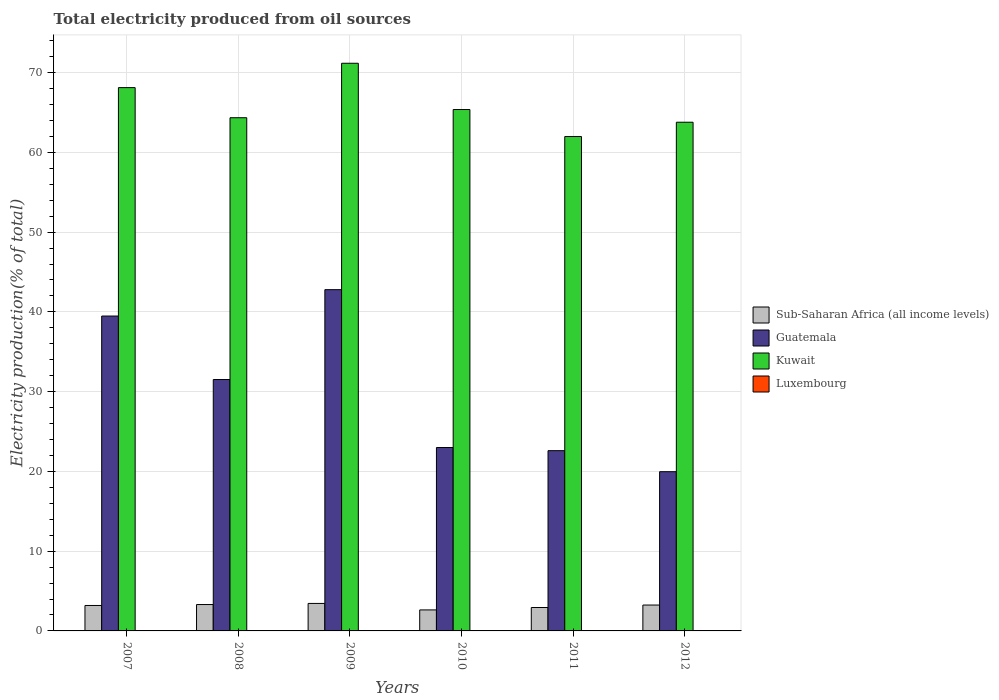How many bars are there on the 2nd tick from the left?
Make the answer very short. 4. How many bars are there on the 2nd tick from the right?
Ensure brevity in your answer.  4. What is the total electricity produced in Sub-Saharan Africa (all income levels) in 2011?
Your answer should be very brief. 2.94. Across all years, what is the maximum total electricity produced in Luxembourg?
Provide a short and direct response. 0.04. Across all years, what is the minimum total electricity produced in Luxembourg?
Keep it short and to the point. 0.03. In which year was the total electricity produced in Luxembourg minimum?
Your answer should be very brief. 2010. What is the total total electricity produced in Guatemala in the graph?
Your answer should be compact. 179.35. What is the difference between the total electricity produced in Sub-Saharan Africa (all income levels) in 2009 and that in 2011?
Offer a very short reply. 0.51. What is the difference between the total electricity produced in Kuwait in 2008 and the total electricity produced in Sub-Saharan Africa (all income levels) in 2007?
Your answer should be compact. 61.16. What is the average total electricity produced in Sub-Saharan Africa (all income levels) per year?
Offer a very short reply. 3.13. In the year 2010, what is the difference between the total electricity produced in Kuwait and total electricity produced in Sub-Saharan Africa (all income levels)?
Ensure brevity in your answer.  62.74. What is the ratio of the total electricity produced in Kuwait in 2008 to that in 2009?
Offer a terse response. 0.9. Is the total electricity produced in Luxembourg in 2009 less than that in 2012?
Your answer should be very brief. Yes. Is the difference between the total electricity produced in Kuwait in 2009 and 2011 greater than the difference between the total electricity produced in Sub-Saharan Africa (all income levels) in 2009 and 2011?
Keep it short and to the point. Yes. What is the difference between the highest and the second highest total electricity produced in Kuwait?
Offer a terse response. 3.06. What is the difference between the highest and the lowest total electricity produced in Kuwait?
Your answer should be very brief. 9.19. Is the sum of the total electricity produced in Kuwait in 2010 and 2011 greater than the maximum total electricity produced in Guatemala across all years?
Keep it short and to the point. Yes. Is it the case that in every year, the sum of the total electricity produced in Luxembourg and total electricity produced in Guatemala is greater than the sum of total electricity produced in Sub-Saharan Africa (all income levels) and total electricity produced in Kuwait?
Keep it short and to the point. Yes. What does the 1st bar from the left in 2009 represents?
Offer a terse response. Sub-Saharan Africa (all income levels). What does the 1st bar from the right in 2008 represents?
Offer a terse response. Luxembourg. How many bars are there?
Ensure brevity in your answer.  24. How many years are there in the graph?
Keep it short and to the point. 6. Are the values on the major ticks of Y-axis written in scientific E-notation?
Provide a succinct answer. No. Does the graph contain any zero values?
Your answer should be compact. No. How many legend labels are there?
Your answer should be compact. 4. How are the legend labels stacked?
Provide a succinct answer. Vertical. What is the title of the graph?
Offer a very short reply. Total electricity produced from oil sources. Does "Myanmar" appear as one of the legend labels in the graph?
Your answer should be compact. No. What is the label or title of the X-axis?
Your answer should be compact. Years. What is the Electricity production(% of total) in Sub-Saharan Africa (all income levels) in 2007?
Provide a succinct answer. 3.19. What is the Electricity production(% of total) in Guatemala in 2007?
Your response must be concise. 39.48. What is the Electricity production(% of total) of Kuwait in 2007?
Your answer should be very brief. 68.12. What is the Electricity production(% of total) in Luxembourg in 2007?
Provide a succinct answer. 0.03. What is the Electricity production(% of total) of Sub-Saharan Africa (all income levels) in 2008?
Keep it short and to the point. 3.31. What is the Electricity production(% of total) in Guatemala in 2008?
Your answer should be very brief. 31.52. What is the Electricity production(% of total) of Kuwait in 2008?
Ensure brevity in your answer.  64.35. What is the Electricity production(% of total) in Luxembourg in 2008?
Keep it short and to the point. 0.04. What is the Electricity production(% of total) of Sub-Saharan Africa (all income levels) in 2009?
Your answer should be very brief. 3.45. What is the Electricity production(% of total) of Guatemala in 2009?
Keep it short and to the point. 42.79. What is the Electricity production(% of total) in Kuwait in 2009?
Offer a very short reply. 71.18. What is the Electricity production(% of total) in Luxembourg in 2009?
Offer a very short reply. 0.03. What is the Electricity production(% of total) of Sub-Saharan Africa (all income levels) in 2010?
Give a very brief answer. 2.63. What is the Electricity production(% of total) of Guatemala in 2010?
Give a very brief answer. 23. What is the Electricity production(% of total) of Kuwait in 2010?
Offer a terse response. 65.38. What is the Electricity production(% of total) in Luxembourg in 2010?
Provide a succinct answer. 0.03. What is the Electricity production(% of total) of Sub-Saharan Africa (all income levels) in 2011?
Your response must be concise. 2.94. What is the Electricity production(% of total) of Guatemala in 2011?
Your answer should be very brief. 22.6. What is the Electricity production(% of total) of Kuwait in 2011?
Ensure brevity in your answer.  61.99. What is the Electricity production(% of total) of Luxembourg in 2011?
Ensure brevity in your answer.  0.04. What is the Electricity production(% of total) in Sub-Saharan Africa (all income levels) in 2012?
Keep it short and to the point. 3.24. What is the Electricity production(% of total) in Guatemala in 2012?
Provide a succinct answer. 19.96. What is the Electricity production(% of total) in Kuwait in 2012?
Your answer should be compact. 63.78. What is the Electricity production(% of total) in Luxembourg in 2012?
Provide a succinct answer. 0.04. Across all years, what is the maximum Electricity production(% of total) of Sub-Saharan Africa (all income levels)?
Keep it short and to the point. 3.45. Across all years, what is the maximum Electricity production(% of total) in Guatemala?
Make the answer very short. 42.79. Across all years, what is the maximum Electricity production(% of total) in Kuwait?
Offer a terse response. 71.18. Across all years, what is the maximum Electricity production(% of total) in Luxembourg?
Make the answer very short. 0.04. Across all years, what is the minimum Electricity production(% of total) of Sub-Saharan Africa (all income levels)?
Offer a very short reply. 2.63. Across all years, what is the minimum Electricity production(% of total) of Guatemala?
Ensure brevity in your answer.  19.96. Across all years, what is the minimum Electricity production(% of total) in Kuwait?
Ensure brevity in your answer.  61.99. Across all years, what is the minimum Electricity production(% of total) of Luxembourg?
Your response must be concise. 0.03. What is the total Electricity production(% of total) of Sub-Saharan Africa (all income levels) in the graph?
Offer a very short reply. 18.76. What is the total Electricity production(% of total) of Guatemala in the graph?
Provide a short and direct response. 179.35. What is the total Electricity production(% of total) of Kuwait in the graph?
Make the answer very short. 394.79. What is the total Electricity production(% of total) in Luxembourg in the graph?
Offer a very short reply. 0.2. What is the difference between the Electricity production(% of total) of Sub-Saharan Africa (all income levels) in 2007 and that in 2008?
Your answer should be compact. -0.12. What is the difference between the Electricity production(% of total) in Guatemala in 2007 and that in 2008?
Provide a succinct answer. 7.96. What is the difference between the Electricity production(% of total) in Kuwait in 2007 and that in 2008?
Ensure brevity in your answer.  3.77. What is the difference between the Electricity production(% of total) of Luxembourg in 2007 and that in 2008?
Offer a very short reply. -0.01. What is the difference between the Electricity production(% of total) of Sub-Saharan Africa (all income levels) in 2007 and that in 2009?
Give a very brief answer. -0.26. What is the difference between the Electricity production(% of total) of Guatemala in 2007 and that in 2009?
Keep it short and to the point. -3.31. What is the difference between the Electricity production(% of total) in Kuwait in 2007 and that in 2009?
Your answer should be compact. -3.06. What is the difference between the Electricity production(% of total) in Luxembourg in 2007 and that in 2009?
Offer a very short reply. -0. What is the difference between the Electricity production(% of total) in Sub-Saharan Africa (all income levels) in 2007 and that in 2010?
Offer a very short reply. 0.56. What is the difference between the Electricity production(% of total) of Guatemala in 2007 and that in 2010?
Ensure brevity in your answer.  16.49. What is the difference between the Electricity production(% of total) in Kuwait in 2007 and that in 2010?
Your answer should be compact. 2.75. What is the difference between the Electricity production(% of total) of Luxembourg in 2007 and that in 2010?
Provide a short and direct response. 0. What is the difference between the Electricity production(% of total) of Sub-Saharan Africa (all income levels) in 2007 and that in 2011?
Offer a very short reply. 0.26. What is the difference between the Electricity production(% of total) in Guatemala in 2007 and that in 2011?
Ensure brevity in your answer.  16.88. What is the difference between the Electricity production(% of total) of Kuwait in 2007 and that in 2011?
Give a very brief answer. 6.13. What is the difference between the Electricity production(% of total) in Luxembourg in 2007 and that in 2011?
Your response must be concise. -0.01. What is the difference between the Electricity production(% of total) in Sub-Saharan Africa (all income levels) in 2007 and that in 2012?
Offer a terse response. -0.05. What is the difference between the Electricity production(% of total) of Guatemala in 2007 and that in 2012?
Provide a short and direct response. 19.52. What is the difference between the Electricity production(% of total) of Kuwait in 2007 and that in 2012?
Ensure brevity in your answer.  4.34. What is the difference between the Electricity production(% of total) in Luxembourg in 2007 and that in 2012?
Offer a very short reply. -0.01. What is the difference between the Electricity production(% of total) in Sub-Saharan Africa (all income levels) in 2008 and that in 2009?
Your answer should be compact. -0.14. What is the difference between the Electricity production(% of total) in Guatemala in 2008 and that in 2009?
Keep it short and to the point. -11.27. What is the difference between the Electricity production(% of total) of Kuwait in 2008 and that in 2009?
Your answer should be compact. -6.83. What is the difference between the Electricity production(% of total) of Luxembourg in 2008 and that in 2009?
Your answer should be very brief. 0.01. What is the difference between the Electricity production(% of total) in Sub-Saharan Africa (all income levels) in 2008 and that in 2010?
Keep it short and to the point. 0.67. What is the difference between the Electricity production(% of total) of Guatemala in 2008 and that in 2010?
Offer a terse response. 8.53. What is the difference between the Electricity production(% of total) in Kuwait in 2008 and that in 2010?
Keep it short and to the point. -1.03. What is the difference between the Electricity production(% of total) in Luxembourg in 2008 and that in 2010?
Give a very brief answer. 0.01. What is the difference between the Electricity production(% of total) in Sub-Saharan Africa (all income levels) in 2008 and that in 2011?
Provide a succinct answer. 0.37. What is the difference between the Electricity production(% of total) in Guatemala in 2008 and that in 2011?
Keep it short and to the point. 8.92. What is the difference between the Electricity production(% of total) of Kuwait in 2008 and that in 2011?
Your answer should be compact. 2.36. What is the difference between the Electricity production(% of total) in Luxembourg in 2008 and that in 2011?
Your response must be concise. -0. What is the difference between the Electricity production(% of total) of Sub-Saharan Africa (all income levels) in 2008 and that in 2012?
Make the answer very short. 0.06. What is the difference between the Electricity production(% of total) in Guatemala in 2008 and that in 2012?
Keep it short and to the point. 11.56. What is the difference between the Electricity production(% of total) of Kuwait in 2008 and that in 2012?
Keep it short and to the point. 0.56. What is the difference between the Electricity production(% of total) of Sub-Saharan Africa (all income levels) in 2009 and that in 2010?
Give a very brief answer. 0.81. What is the difference between the Electricity production(% of total) of Guatemala in 2009 and that in 2010?
Offer a terse response. 19.79. What is the difference between the Electricity production(% of total) in Kuwait in 2009 and that in 2010?
Your response must be concise. 5.8. What is the difference between the Electricity production(% of total) in Luxembourg in 2009 and that in 2010?
Your answer should be very brief. 0. What is the difference between the Electricity production(% of total) in Sub-Saharan Africa (all income levels) in 2009 and that in 2011?
Ensure brevity in your answer.  0.51. What is the difference between the Electricity production(% of total) of Guatemala in 2009 and that in 2011?
Keep it short and to the point. 20.19. What is the difference between the Electricity production(% of total) in Kuwait in 2009 and that in 2011?
Provide a succinct answer. 9.19. What is the difference between the Electricity production(% of total) of Luxembourg in 2009 and that in 2011?
Ensure brevity in your answer.  -0.01. What is the difference between the Electricity production(% of total) in Sub-Saharan Africa (all income levels) in 2009 and that in 2012?
Give a very brief answer. 0.2. What is the difference between the Electricity production(% of total) in Guatemala in 2009 and that in 2012?
Provide a short and direct response. 22.82. What is the difference between the Electricity production(% of total) of Kuwait in 2009 and that in 2012?
Keep it short and to the point. 7.39. What is the difference between the Electricity production(% of total) of Luxembourg in 2009 and that in 2012?
Your response must be concise. -0. What is the difference between the Electricity production(% of total) in Sub-Saharan Africa (all income levels) in 2010 and that in 2011?
Offer a terse response. -0.3. What is the difference between the Electricity production(% of total) of Guatemala in 2010 and that in 2011?
Your response must be concise. 0.39. What is the difference between the Electricity production(% of total) of Kuwait in 2010 and that in 2011?
Your answer should be compact. 3.39. What is the difference between the Electricity production(% of total) of Luxembourg in 2010 and that in 2011?
Your answer should be compact. -0.01. What is the difference between the Electricity production(% of total) of Sub-Saharan Africa (all income levels) in 2010 and that in 2012?
Give a very brief answer. -0.61. What is the difference between the Electricity production(% of total) of Guatemala in 2010 and that in 2012?
Offer a very short reply. 3.03. What is the difference between the Electricity production(% of total) in Kuwait in 2010 and that in 2012?
Ensure brevity in your answer.  1.59. What is the difference between the Electricity production(% of total) in Luxembourg in 2010 and that in 2012?
Give a very brief answer. -0.01. What is the difference between the Electricity production(% of total) in Sub-Saharan Africa (all income levels) in 2011 and that in 2012?
Your response must be concise. -0.31. What is the difference between the Electricity production(% of total) in Guatemala in 2011 and that in 2012?
Your answer should be compact. 2.64. What is the difference between the Electricity production(% of total) in Kuwait in 2011 and that in 2012?
Ensure brevity in your answer.  -1.8. What is the difference between the Electricity production(% of total) of Luxembourg in 2011 and that in 2012?
Your answer should be compact. 0. What is the difference between the Electricity production(% of total) of Sub-Saharan Africa (all income levels) in 2007 and the Electricity production(% of total) of Guatemala in 2008?
Provide a short and direct response. -28.33. What is the difference between the Electricity production(% of total) of Sub-Saharan Africa (all income levels) in 2007 and the Electricity production(% of total) of Kuwait in 2008?
Give a very brief answer. -61.16. What is the difference between the Electricity production(% of total) in Sub-Saharan Africa (all income levels) in 2007 and the Electricity production(% of total) in Luxembourg in 2008?
Provide a short and direct response. 3.15. What is the difference between the Electricity production(% of total) in Guatemala in 2007 and the Electricity production(% of total) in Kuwait in 2008?
Make the answer very short. -24.87. What is the difference between the Electricity production(% of total) in Guatemala in 2007 and the Electricity production(% of total) in Luxembourg in 2008?
Give a very brief answer. 39.44. What is the difference between the Electricity production(% of total) in Kuwait in 2007 and the Electricity production(% of total) in Luxembourg in 2008?
Your response must be concise. 68.08. What is the difference between the Electricity production(% of total) in Sub-Saharan Africa (all income levels) in 2007 and the Electricity production(% of total) in Guatemala in 2009?
Provide a succinct answer. -39.6. What is the difference between the Electricity production(% of total) of Sub-Saharan Africa (all income levels) in 2007 and the Electricity production(% of total) of Kuwait in 2009?
Provide a succinct answer. -67.98. What is the difference between the Electricity production(% of total) of Sub-Saharan Africa (all income levels) in 2007 and the Electricity production(% of total) of Luxembourg in 2009?
Give a very brief answer. 3.16. What is the difference between the Electricity production(% of total) in Guatemala in 2007 and the Electricity production(% of total) in Kuwait in 2009?
Ensure brevity in your answer.  -31.69. What is the difference between the Electricity production(% of total) of Guatemala in 2007 and the Electricity production(% of total) of Luxembourg in 2009?
Ensure brevity in your answer.  39.45. What is the difference between the Electricity production(% of total) in Kuwait in 2007 and the Electricity production(% of total) in Luxembourg in 2009?
Provide a succinct answer. 68.09. What is the difference between the Electricity production(% of total) in Sub-Saharan Africa (all income levels) in 2007 and the Electricity production(% of total) in Guatemala in 2010?
Ensure brevity in your answer.  -19.8. What is the difference between the Electricity production(% of total) of Sub-Saharan Africa (all income levels) in 2007 and the Electricity production(% of total) of Kuwait in 2010?
Keep it short and to the point. -62.18. What is the difference between the Electricity production(% of total) of Sub-Saharan Africa (all income levels) in 2007 and the Electricity production(% of total) of Luxembourg in 2010?
Keep it short and to the point. 3.16. What is the difference between the Electricity production(% of total) of Guatemala in 2007 and the Electricity production(% of total) of Kuwait in 2010?
Offer a terse response. -25.89. What is the difference between the Electricity production(% of total) of Guatemala in 2007 and the Electricity production(% of total) of Luxembourg in 2010?
Make the answer very short. 39.45. What is the difference between the Electricity production(% of total) in Kuwait in 2007 and the Electricity production(% of total) in Luxembourg in 2010?
Provide a short and direct response. 68.09. What is the difference between the Electricity production(% of total) in Sub-Saharan Africa (all income levels) in 2007 and the Electricity production(% of total) in Guatemala in 2011?
Keep it short and to the point. -19.41. What is the difference between the Electricity production(% of total) in Sub-Saharan Africa (all income levels) in 2007 and the Electricity production(% of total) in Kuwait in 2011?
Provide a succinct answer. -58.8. What is the difference between the Electricity production(% of total) in Sub-Saharan Africa (all income levels) in 2007 and the Electricity production(% of total) in Luxembourg in 2011?
Give a very brief answer. 3.15. What is the difference between the Electricity production(% of total) in Guatemala in 2007 and the Electricity production(% of total) in Kuwait in 2011?
Provide a short and direct response. -22.51. What is the difference between the Electricity production(% of total) in Guatemala in 2007 and the Electricity production(% of total) in Luxembourg in 2011?
Make the answer very short. 39.44. What is the difference between the Electricity production(% of total) in Kuwait in 2007 and the Electricity production(% of total) in Luxembourg in 2011?
Provide a short and direct response. 68.08. What is the difference between the Electricity production(% of total) in Sub-Saharan Africa (all income levels) in 2007 and the Electricity production(% of total) in Guatemala in 2012?
Give a very brief answer. -16.77. What is the difference between the Electricity production(% of total) of Sub-Saharan Africa (all income levels) in 2007 and the Electricity production(% of total) of Kuwait in 2012?
Your answer should be compact. -60.59. What is the difference between the Electricity production(% of total) of Sub-Saharan Africa (all income levels) in 2007 and the Electricity production(% of total) of Luxembourg in 2012?
Your response must be concise. 3.15. What is the difference between the Electricity production(% of total) of Guatemala in 2007 and the Electricity production(% of total) of Kuwait in 2012?
Your answer should be compact. -24.3. What is the difference between the Electricity production(% of total) of Guatemala in 2007 and the Electricity production(% of total) of Luxembourg in 2012?
Keep it short and to the point. 39.45. What is the difference between the Electricity production(% of total) in Kuwait in 2007 and the Electricity production(% of total) in Luxembourg in 2012?
Your answer should be very brief. 68.08. What is the difference between the Electricity production(% of total) in Sub-Saharan Africa (all income levels) in 2008 and the Electricity production(% of total) in Guatemala in 2009?
Give a very brief answer. -39.48. What is the difference between the Electricity production(% of total) of Sub-Saharan Africa (all income levels) in 2008 and the Electricity production(% of total) of Kuwait in 2009?
Make the answer very short. -67.87. What is the difference between the Electricity production(% of total) in Sub-Saharan Africa (all income levels) in 2008 and the Electricity production(% of total) in Luxembourg in 2009?
Provide a succinct answer. 3.28. What is the difference between the Electricity production(% of total) in Guatemala in 2008 and the Electricity production(% of total) in Kuwait in 2009?
Keep it short and to the point. -39.66. What is the difference between the Electricity production(% of total) in Guatemala in 2008 and the Electricity production(% of total) in Luxembourg in 2009?
Provide a succinct answer. 31.49. What is the difference between the Electricity production(% of total) in Kuwait in 2008 and the Electricity production(% of total) in Luxembourg in 2009?
Your answer should be very brief. 64.32. What is the difference between the Electricity production(% of total) of Sub-Saharan Africa (all income levels) in 2008 and the Electricity production(% of total) of Guatemala in 2010?
Provide a short and direct response. -19.69. What is the difference between the Electricity production(% of total) in Sub-Saharan Africa (all income levels) in 2008 and the Electricity production(% of total) in Kuwait in 2010?
Provide a succinct answer. -62.07. What is the difference between the Electricity production(% of total) of Sub-Saharan Africa (all income levels) in 2008 and the Electricity production(% of total) of Luxembourg in 2010?
Provide a short and direct response. 3.28. What is the difference between the Electricity production(% of total) of Guatemala in 2008 and the Electricity production(% of total) of Kuwait in 2010?
Ensure brevity in your answer.  -33.85. What is the difference between the Electricity production(% of total) in Guatemala in 2008 and the Electricity production(% of total) in Luxembourg in 2010?
Provide a short and direct response. 31.49. What is the difference between the Electricity production(% of total) of Kuwait in 2008 and the Electricity production(% of total) of Luxembourg in 2010?
Provide a short and direct response. 64.32. What is the difference between the Electricity production(% of total) of Sub-Saharan Africa (all income levels) in 2008 and the Electricity production(% of total) of Guatemala in 2011?
Offer a terse response. -19.29. What is the difference between the Electricity production(% of total) in Sub-Saharan Africa (all income levels) in 2008 and the Electricity production(% of total) in Kuwait in 2011?
Make the answer very short. -58.68. What is the difference between the Electricity production(% of total) in Sub-Saharan Africa (all income levels) in 2008 and the Electricity production(% of total) in Luxembourg in 2011?
Your answer should be very brief. 3.27. What is the difference between the Electricity production(% of total) in Guatemala in 2008 and the Electricity production(% of total) in Kuwait in 2011?
Make the answer very short. -30.47. What is the difference between the Electricity production(% of total) of Guatemala in 2008 and the Electricity production(% of total) of Luxembourg in 2011?
Your response must be concise. 31.48. What is the difference between the Electricity production(% of total) in Kuwait in 2008 and the Electricity production(% of total) in Luxembourg in 2011?
Provide a succinct answer. 64.31. What is the difference between the Electricity production(% of total) of Sub-Saharan Africa (all income levels) in 2008 and the Electricity production(% of total) of Guatemala in 2012?
Your response must be concise. -16.66. What is the difference between the Electricity production(% of total) of Sub-Saharan Africa (all income levels) in 2008 and the Electricity production(% of total) of Kuwait in 2012?
Ensure brevity in your answer.  -60.48. What is the difference between the Electricity production(% of total) in Sub-Saharan Africa (all income levels) in 2008 and the Electricity production(% of total) in Luxembourg in 2012?
Offer a very short reply. 3.27. What is the difference between the Electricity production(% of total) of Guatemala in 2008 and the Electricity production(% of total) of Kuwait in 2012?
Your response must be concise. -32.26. What is the difference between the Electricity production(% of total) in Guatemala in 2008 and the Electricity production(% of total) in Luxembourg in 2012?
Provide a short and direct response. 31.48. What is the difference between the Electricity production(% of total) of Kuwait in 2008 and the Electricity production(% of total) of Luxembourg in 2012?
Your answer should be very brief. 64.31. What is the difference between the Electricity production(% of total) of Sub-Saharan Africa (all income levels) in 2009 and the Electricity production(% of total) of Guatemala in 2010?
Your answer should be very brief. -19.55. What is the difference between the Electricity production(% of total) in Sub-Saharan Africa (all income levels) in 2009 and the Electricity production(% of total) in Kuwait in 2010?
Offer a terse response. -61.93. What is the difference between the Electricity production(% of total) of Sub-Saharan Africa (all income levels) in 2009 and the Electricity production(% of total) of Luxembourg in 2010?
Your response must be concise. 3.42. What is the difference between the Electricity production(% of total) in Guatemala in 2009 and the Electricity production(% of total) in Kuwait in 2010?
Provide a short and direct response. -22.59. What is the difference between the Electricity production(% of total) in Guatemala in 2009 and the Electricity production(% of total) in Luxembourg in 2010?
Provide a short and direct response. 42.76. What is the difference between the Electricity production(% of total) of Kuwait in 2009 and the Electricity production(% of total) of Luxembourg in 2010?
Your response must be concise. 71.14. What is the difference between the Electricity production(% of total) in Sub-Saharan Africa (all income levels) in 2009 and the Electricity production(% of total) in Guatemala in 2011?
Your response must be concise. -19.15. What is the difference between the Electricity production(% of total) of Sub-Saharan Africa (all income levels) in 2009 and the Electricity production(% of total) of Kuwait in 2011?
Ensure brevity in your answer.  -58.54. What is the difference between the Electricity production(% of total) of Sub-Saharan Africa (all income levels) in 2009 and the Electricity production(% of total) of Luxembourg in 2011?
Your response must be concise. 3.41. What is the difference between the Electricity production(% of total) in Guatemala in 2009 and the Electricity production(% of total) in Kuwait in 2011?
Your response must be concise. -19.2. What is the difference between the Electricity production(% of total) in Guatemala in 2009 and the Electricity production(% of total) in Luxembourg in 2011?
Offer a terse response. 42.75. What is the difference between the Electricity production(% of total) of Kuwait in 2009 and the Electricity production(% of total) of Luxembourg in 2011?
Provide a short and direct response. 71.14. What is the difference between the Electricity production(% of total) of Sub-Saharan Africa (all income levels) in 2009 and the Electricity production(% of total) of Guatemala in 2012?
Keep it short and to the point. -16.52. What is the difference between the Electricity production(% of total) of Sub-Saharan Africa (all income levels) in 2009 and the Electricity production(% of total) of Kuwait in 2012?
Make the answer very short. -60.34. What is the difference between the Electricity production(% of total) in Sub-Saharan Africa (all income levels) in 2009 and the Electricity production(% of total) in Luxembourg in 2012?
Give a very brief answer. 3.41. What is the difference between the Electricity production(% of total) of Guatemala in 2009 and the Electricity production(% of total) of Kuwait in 2012?
Make the answer very short. -21. What is the difference between the Electricity production(% of total) in Guatemala in 2009 and the Electricity production(% of total) in Luxembourg in 2012?
Your answer should be compact. 42.75. What is the difference between the Electricity production(% of total) of Kuwait in 2009 and the Electricity production(% of total) of Luxembourg in 2012?
Your response must be concise. 71.14. What is the difference between the Electricity production(% of total) in Sub-Saharan Africa (all income levels) in 2010 and the Electricity production(% of total) in Guatemala in 2011?
Give a very brief answer. -19.97. What is the difference between the Electricity production(% of total) in Sub-Saharan Africa (all income levels) in 2010 and the Electricity production(% of total) in Kuwait in 2011?
Provide a succinct answer. -59.35. What is the difference between the Electricity production(% of total) of Sub-Saharan Africa (all income levels) in 2010 and the Electricity production(% of total) of Luxembourg in 2011?
Your answer should be compact. 2.6. What is the difference between the Electricity production(% of total) in Guatemala in 2010 and the Electricity production(% of total) in Kuwait in 2011?
Offer a very short reply. -38.99. What is the difference between the Electricity production(% of total) of Guatemala in 2010 and the Electricity production(% of total) of Luxembourg in 2011?
Make the answer very short. 22.96. What is the difference between the Electricity production(% of total) of Kuwait in 2010 and the Electricity production(% of total) of Luxembourg in 2011?
Your answer should be very brief. 65.34. What is the difference between the Electricity production(% of total) of Sub-Saharan Africa (all income levels) in 2010 and the Electricity production(% of total) of Guatemala in 2012?
Give a very brief answer. -17.33. What is the difference between the Electricity production(% of total) of Sub-Saharan Africa (all income levels) in 2010 and the Electricity production(% of total) of Kuwait in 2012?
Your answer should be very brief. -61.15. What is the difference between the Electricity production(% of total) in Sub-Saharan Africa (all income levels) in 2010 and the Electricity production(% of total) in Luxembourg in 2012?
Offer a very short reply. 2.6. What is the difference between the Electricity production(% of total) of Guatemala in 2010 and the Electricity production(% of total) of Kuwait in 2012?
Your response must be concise. -40.79. What is the difference between the Electricity production(% of total) in Guatemala in 2010 and the Electricity production(% of total) in Luxembourg in 2012?
Your answer should be very brief. 22.96. What is the difference between the Electricity production(% of total) in Kuwait in 2010 and the Electricity production(% of total) in Luxembourg in 2012?
Your answer should be very brief. 65.34. What is the difference between the Electricity production(% of total) of Sub-Saharan Africa (all income levels) in 2011 and the Electricity production(% of total) of Guatemala in 2012?
Provide a succinct answer. -17.03. What is the difference between the Electricity production(% of total) of Sub-Saharan Africa (all income levels) in 2011 and the Electricity production(% of total) of Kuwait in 2012?
Offer a terse response. -60.85. What is the difference between the Electricity production(% of total) in Sub-Saharan Africa (all income levels) in 2011 and the Electricity production(% of total) in Luxembourg in 2012?
Your answer should be very brief. 2.9. What is the difference between the Electricity production(% of total) in Guatemala in 2011 and the Electricity production(% of total) in Kuwait in 2012?
Give a very brief answer. -41.18. What is the difference between the Electricity production(% of total) in Guatemala in 2011 and the Electricity production(% of total) in Luxembourg in 2012?
Offer a terse response. 22.56. What is the difference between the Electricity production(% of total) of Kuwait in 2011 and the Electricity production(% of total) of Luxembourg in 2012?
Give a very brief answer. 61.95. What is the average Electricity production(% of total) in Sub-Saharan Africa (all income levels) per year?
Your answer should be very brief. 3.13. What is the average Electricity production(% of total) of Guatemala per year?
Keep it short and to the point. 29.89. What is the average Electricity production(% of total) of Kuwait per year?
Keep it short and to the point. 65.8. What is the average Electricity production(% of total) of Luxembourg per year?
Your answer should be very brief. 0.03. In the year 2007, what is the difference between the Electricity production(% of total) of Sub-Saharan Africa (all income levels) and Electricity production(% of total) of Guatemala?
Give a very brief answer. -36.29. In the year 2007, what is the difference between the Electricity production(% of total) in Sub-Saharan Africa (all income levels) and Electricity production(% of total) in Kuwait?
Offer a terse response. -64.93. In the year 2007, what is the difference between the Electricity production(% of total) in Sub-Saharan Africa (all income levels) and Electricity production(% of total) in Luxembourg?
Provide a succinct answer. 3.16. In the year 2007, what is the difference between the Electricity production(% of total) of Guatemala and Electricity production(% of total) of Kuwait?
Offer a very short reply. -28.64. In the year 2007, what is the difference between the Electricity production(% of total) of Guatemala and Electricity production(% of total) of Luxembourg?
Ensure brevity in your answer.  39.45. In the year 2007, what is the difference between the Electricity production(% of total) of Kuwait and Electricity production(% of total) of Luxembourg?
Provide a short and direct response. 68.09. In the year 2008, what is the difference between the Electricity production(% of total) of Sub-Saharan Africa (all income levels) and Electricity production(% of total) of Guatemala?
Ensure brevity in your answer.  -28.21. In the year 2008, what is the difference between the Electricity production(% of total) in Sub-Saharan Africa (all income levels) and Electricity production(% of total) in Kuwait?
Provide a short and direct response. -61.04. In the year 2008, what is the difference between the Electricity production(% of total) of Sub-Saharan Africa (all income levels) and Electricity production(% of total) of Luxembourg?
Your answer should be compact. 3.27. In the year 2008, what is the difference between the Electricity production(% of total) in Guatemala and Electricity production(% of total) in Kuwait?
Your answer should be very brief. -32.83. In the year 2008, what is the difference between the Electricity production(% of total) in Guatemala and Electricity production(% of total) in Luxembourg?
Offer a terse response. 31.48. In the year 2008, what is the difference between the Electricity production(% of total) of Kuwait and Electricity production(% of total) of Luxembourg?
Your answer should be very brief. 64.31. In the year 2009, what is the difference between the Electricity production(% of total) in Sub-Saharan Africa (all income levels) and Electricity production(% of total) in Guatemala?
Offer a terse response. -39.34. In the year 2009, what is the difference between the Electricity production(% of total) in Sub-Saharan Africa (all income levels) and Electricity production(% of total) in Kuwait?
Offer a terse response. -67.73. In the year 2009, what is the difference between the Electricity production(% of total) in Sub-Saharan Africa (all income levels) and Electricity production(% of total) in Luxembourg?
Your response must be concise. 3.41. In the year 2009, what is the difference between the Electricity production(% of total) of Guatemala and Electricity production(% of total) of Kuwait?
Provide a short and direct response. -28.39. In the year 2009, what is the difference between the Electricity production(% of total) in Guatemala and Electricity production(% of total) in Luxembourg?
Offer a terse response. 42.76. In the year 2009, what is the difference between the Electricity production(% of total) of Kuwait and Electricity production(% of total) of Luxembourg?
Make the answer very short. 71.14. In the year 2010, what is the difference between the Electricity production(% of total) of Sub-Saharan Africa (all income levels) and Electricity production(% of total) of Guatemala?
Offer a terse response. -20.36. In the year 2010, what is the difference between the Electricity production(% of total) of Sub-Saharan Africa (all income levels) and Electricity production(% of total) of Kuwait?
Keep it short and to the point. -62.74. In the year 2010, what is the difference between the Electricity production(% of total) of Sub-Saharan Africa (all income levels) and Electricity production(% of total) of Luxembourg?
Provide a succinct answer. 2.6. In the year 2010, what is the difference between the Electricity production(% of total) of Guatemala and Electricity production(% of total) of Kuwait?
Provide a short and direct response. -42.38. In the year 2010, what is the difference between the Electricity production(% of total) of Guatemala and Electricity production(% of total) of Luxembourg?
Your answer should be very brief. 22.96. In the year 2010, what is the difference between the Electricity production(% of total) in Kuwait and Electricity production(% of total) in Luxembourg?
Offer a terse response. 65.34. In the year 2011, what is the difference between the Electricity production(% of total) of Sub-Saharan Africa (all income levels) and Electricity production(% of total) of Guatemala?
Ensure brevity in your answer.  -19.67. In the year 2011, what is the difference between the Electricity production(% of total) of Sub-Saharan Africa (all income levels) and Electricity production(% of total) of Kuwait?
Offer a very short reply. -59.05. In the year 2011, what is the difference between the Electricity production(% of total) of Sub-Saharan Africa (all income levels) and Electricity production(% of total) of Luxembourg?
Give a very brief answer. 2.9. In the year 2011, what is the difference between the Electricity production(% of total) in Guatemala and Electricity production(% of total) in Kuwait?
Provide a succinct answer. -39.39. In the year 2011, what is the difference between the Electricity production(% of total) of Guatemala and Electricity production(% of total) of Luxembourg?
Your answer should be very brief. 22.56. In the year 2011, what is the difference between the Electricity production(% of total) of Kuwait and Electricity production(% of total) of Luxembourg?
Ensure brevity in your answer.  61.95. In the year 2012, what is the difference between the Electricity production(% of total) in Sub-Saharan Africa (all income levels) and Electricity production(% of total) in Guatemala?
Your answer should be compact. -16.72. In the year 2012, what is the difference between the Electricity production(% of total) of Sub-Saharan Africa (all income levels) and Electricity production(% of total) of Kuwait?
Keep it short and to the point. -60.54. In the year 2012, what is the difference between the Electricity production(% of total) in Sub-Saharan Africa (all income levels) and Electricity production(% of total) in Luxembourg?
Offer a very short reply. 3.21. In the year 2012, what is the difference between the Electricity production(% of total) in Guatemala and Electricity production(% of total) in Kuwait?
Give a very brief answer. -43.82. In the year 2012, what is the difference between the Electricity production(% of total) in Guatemala and Electricity production(% of total) in Luxembourg?
Your answer should be very brief. 19.93. In the year 2012, what is the difference between the Electricity production(% of total) of Kuwait and Electricity production(% of total) of Luxembourg?
Provide a succinct answer. 63.75. What is the ratio of the Electricity production(% of total) of Sub-Saharan Africa (all income levels) in 2007 to that in 2008?
Give a very brief answer. 0.96. What is the ratio of the Electricity production(% of total) of Guatemala in 2007 to that in 2008?
Your answer should be very brief. 1.25. What is the ratio of the Electricity production(% of total) of Kuwait in 2007 to that in 2008?
Offer a very short reply. 1.06. What is the ratio of the Electricity production(% of total) of Luxembourg in 2007 to that in 2008?
Provide a succinct answer. 0.85. What is the ratio of the Electricity production(% of total) in Sub-Saharan Africa (all income levels) in 2007 to that in 2009?
Provide a succinct answer. 0.93. What is the ratio of the Electricity production(% of total) of Guatemala in 2007 to that in 2009?
Ensure brevity in your answer.  0.92. What is the ratio of the Electricity production(% of total) of Kuwait in 2007 to that in 2009?
Your answer should be very brief. 0.96. What is the ratio of the Electricity production(% of total) of Luxembourg in 2007 to that in 2009?
Ensure brevity in your answer.  0.98. What is the ratio of the Electricity production(% of total) in Sub-Saharan Africa (all income levels) in 2007 to that in 2010?
Give a very brief answer. 1.21. What is the ratio of the Electricity production(% of total) in Guatemala in 2007 to that in 2010?
Keep it short and to the point. 1.72. What is the ratio of the Electricity production(% of total) in Kuwait in 2007 to that in 2010?
Ensure brevity in your answer.  1.04. What is the ratio of the Electricity production(% of total) in Luxembourg in 2007 to that in 2010?
Your answer should be very brief. 1.01. What is the ratio of the Electricity production(% of total) of Sub-Saharan Africa (all income levels) in 2007 to that in 2011?
Ensure brevity in your answer.  1.09. What is the ratio of the Electricity production(% of total) in Guatemala in 2007 to that in 2011?
Keep it short and to the point. 1.75. What is the ratio of the Electricity production(% of total) in Kuwait in 2007 to that in 2011?
Provide a short and direct response. 1.1. What is the ratio of the Electricity production(% of total) of Luxembourg in 2007 to that in 2011?
Give a very brief answer. 0.83. What is the ratio of the Electricity production(% of total) of Sub-Saharan Africa (all income levels) in 2007 to that in 2012?
Offer a terse response. 0.98. What is the ratio of the Electricity production(% of total) in Guatemala in 2007 to that in 2012?
Your answer should be very brief. 1.98. What is the ratio of the Electricity production(% of total) in Kuwait in 2007 to that in 2012?
Your answer should be very brief. 1.07. What is the ratio of the Electricity production(% of total) in Luxembourg in 2007 to that in 2012?
Your answer should be very brief. 0.86. What is the ratio of the Electricity production(% of total) in Sub-Saharan Africa (all income levels) in 2008 to that in 2009?
Provide a succinct answer. 0.96. What is the ratio of the Electricity production(% of total) of Guatemala in 2008 to that in 2009?
Offer a very short reply. 0.74. What is the ratio of the Electricity production(% of total) of Kuwait in 2008 to that in 2009?
Give a very brief answer. 0.9. What is the ratio of the Electricity production(% of total) of Luxembourg in 2008 to that in 2009?
Give a very brief answer. 1.16. What is the ratio of the Electricity production(% of total) in Sub-Saharan Africa (all income levels) in 2008 to that in 2010?
Ensure brevity in your answer.  1.26. What is the ratio of the Electricity production(% of total) of Guatemala in 2008 to that in 2010?
Your response must be concise. 1.37. What is the ratio of the Electricity production(% of total) in Kuwait in 2008 to that in 2010?
Provide a short and direct response. 0.98. What is the ratio of the Electricity production(% of total) of Luxembourg in 2008 to that in 2010?
Keep it short and to the point. 1.18. What is the ratio of the Electricity production(% of total) of Sub-Saharan Africa (all income levels) in 2008 to that in 2011?
Your answer should be very brief. 1.13. What is the ratio of the Electricity production(% of total) of Guatemala in 2008 to that in 2011?
Give a very brief answer. 1.39. What is the ratio of the Electricity production(% of total) in Kuwait in 2008 to that in 2011?
Your response must be concise. 1.04. What is the ratio of the Electricity production(% of total) in Luxembourg in 2008 to that in 2011?
Make the answer very short. 0.97. What is the ratio of the Electricity production(% of total) in Sub-Saharan Africa (all income levels) in 2008 to that in 2012?
Your answer should be very brief. 1.02. What is the ratio of the Electricity production(% of total) of Guatemala in 2008 to that in 2012?
Make the answer very short. 1.58. What is the ratio of the Electricity production(% of total) of Kuwait in 2008 to that in 2012?
Your answer should be very brief. 1.01. What is the ratio of the Electricity production(% of total) of Luxembourg in 2008 to that in 2012?
Offer a very short reply. 1.01. What is the ratio of the Electricity production(% of total) in Sub-Saharan Africa (all income levels) in 2009 to that in 2010?
Keep it short and to the point. 1.31. What is the ratio of the Electricity production(% of total) in Guatemala in 2009 to that in 2010?
Give a very brief answer. 1.86. What is the ratio of the Electricity production(% of total) of Kuwait in 2009 to that in 2010?
Keep it short and to the point. 1.09. What is the ratio of the Electricity production(% of total) of Luxembourg in 2009 to that in 2010?
Your answer should be very brief. 1.02. What is the ratio of the Electricity production(% of total) of Sub-Saharan Africa (all income levels) in 2009 to that in 2011?
Your answer should be compact. 1.17. What is the ratio of the Electricity production(% of total) of Guatemala in 2009 to that in 2011?
Your response must be concise. 1.89. What is the ratio of the Electricity production(% of total) of Kuwait in 2009 to that in 2011?
Provide a short and direct response. 1.15. What is the ratio of the Electricity production(% of total) of Luxembourg in 2009 to that in 2011?
Your answer should be very brief. 0.84. What is the ratio of the Electricity production(% of total) in Sub-Saharan Africa (all income levels) in 2009 to that in 2012?
Your answer should be very brief. 1.06. What is the ratio of the Electricity production(% of total) in Guatemala in 2009 to that in 2012?
Your answer should be very brief. 2.14. What is the ratio of the Electricity production(% of total) of Kuwait in 2009 to that in 2012?
Ensure brevity in your answer.  1.12. What is the ratio of the Electricity production(% of total) of Luxembourg in 2009 to that in 2012?
Ensure brevity in your answer.  0.87. What is the ratio of the Electricity production(% of total) of Sub-Saharan Africa (all income levels) in 2010 to that in 2011?
Your answer should be very brief. 0.9. What is the ratio of the Electricity production(% of total) in Guatemala in 2010 to that in 2011?
Give a very brief answer. 1.02. What is the ratio of the Electricity production(% of total) of Kuwait in 2010 to that in 2011?
Make the answer very short. 1.05. What is the ratio of the Electricity production(% of total) of Luxembourg in 2010 to that in 2011?
Ensure brevity in your answer.  0.82. What is the ratio of the Electricity production(% of total) of Sub-Saharan Africa (all income levels) in 2010 to that in 2012?
Provide a short and direct response. 0.81. What is the ratio of the Electricity production(% of total) of Guatemala in 2010 to that in 2012?
Offer a terse response. 1.15. What is the ratio of the Electricity production(% of total) of Kuwait in 2010 to that in 2012?
Ensure brevity in your answer.  1.02. What is the ratio of the Electricity production(% of total) of Luxembourg in 2010 to that in 2012?
Provide a short and direct response. 0.85. What is the ratio of the Electricity production(% of total) in Sub-Saharan Africa (all income levels) in 2011 to that in 2012?
Ensure brevity in your answer.  0.9. What is the ratio of the Electricity production(% of total) of Guatemala in 2011 to that in 2012?
Offer a terse response. 1.13. What is the ratio of the Electricity production(% of total) in Kuwait in 2011 to that in 2012?
Offer a very short reply. 0.97. What is the ratio of the Electricity production(% of total) in Luxembourg in 2011 to that in 2012?
Keep it short and to the point. 1.04. What is the difference between the highest and the second highest Electricity production(% of total) of Sub-Saharan Africa (all income levels)?
Your answer should be very brief. 0.14. What is the difference between the highest and the second highest Electricity production(% of total) of Guatemala?
Offer a terse response. 3.31. What is the difference between the highest and the second highest Electricity production(% of total) in Kuwait?
Provide a short and direct response. 3.06. What is the difference between the highest and the second highest Electricity production(% of total) in Luxembourg?
Your response must be concise. 0. What is the difference between the highest and the lowest Electricity production(% of total) in Sub-Saharan Africa (all income levels)?
Ensure brevity in your answer.  0.81. What is the difference between the highest and the lowest Electricity production(% of total) of Guatemala?
Your response must be concise. 22.82. What is the difference between the highest and the lowest Electricity production(% of total) in Kuwait?
Keep it short and to the point. 9.19. What is the difference between the highest and the lowest Electricity production(% of total) in Luxembourg?
Give a very brief answer. 0.01. 